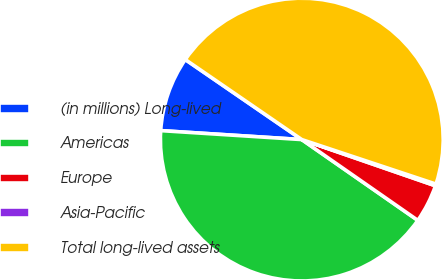Convert chart. <chart><loc_0><loc_0><loc_500><loc_500><pie_chart><fcel>(in millions) Long-lived<fcel>Americas<fcel>Europe<fcel>Asia-Pacific<fcel>Total long-lived assets<nl><fcel>8.57%<fcel>41.33%<fcel>4.38%<fcel>0.2%<fcel>45.52%<nl></chart> 